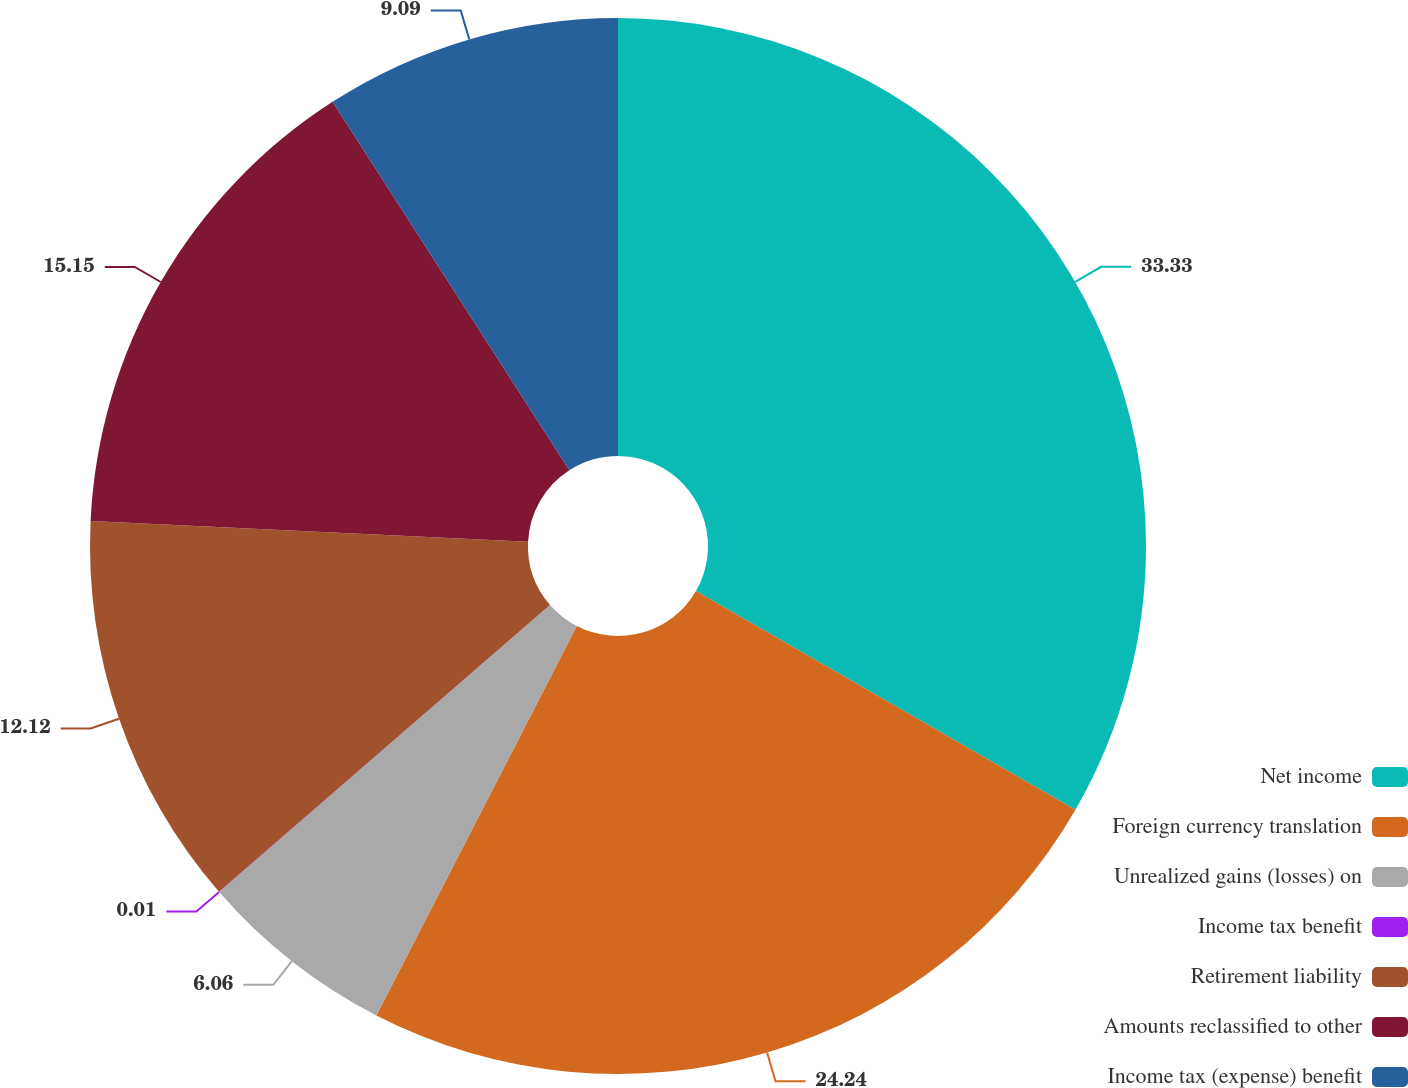<chart> <loc_0><loc_0><loc_500><loc_500><pie_chart><fcel>Net income<fcel>Foreign currency translation<fcel>Unrealized gains (losses) on<fcel>Income tax benefit<fcel>Retirement liability<fcel>Amounts reclassified to other<fcel>Income tax (expense) benefit<nl><fcel>33.32%<fcel>24.24%<fcel>6.06%<fcel>0.01%<fcel>12.12%<fcel>15.15%<fcel>9.09%<nl></chart> 